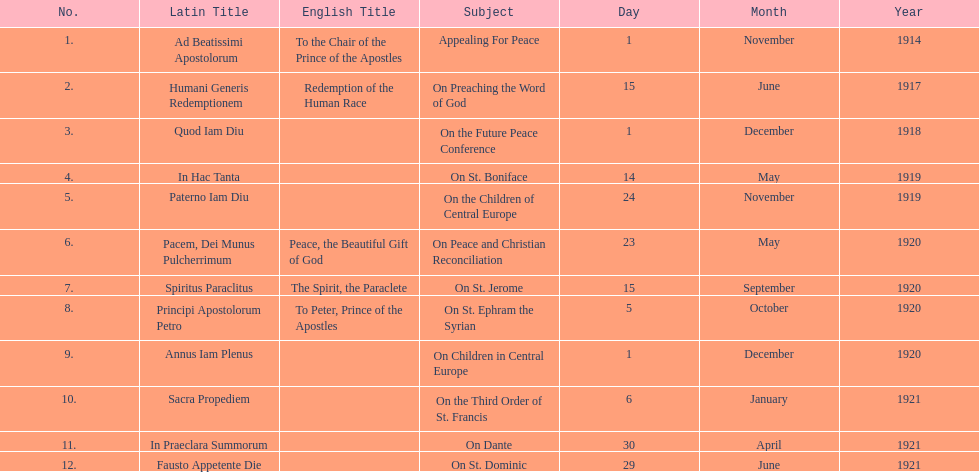What is the subject listed after appealing for peace? On Preaching the Word of God. 